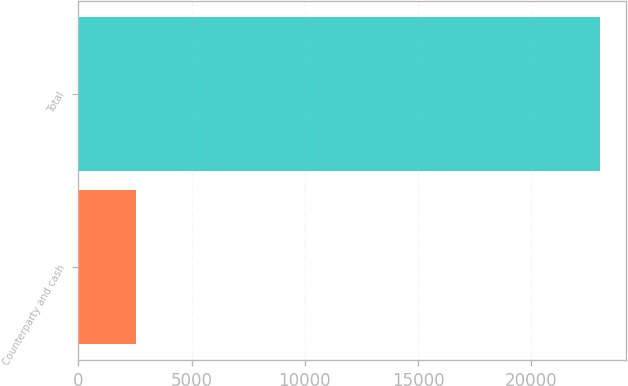Convert chart to OTSL. <chart><loc_0><loc_0><loc_500><loc_500><bar_chart><fcel>Counterparty and cash<fcel>Total<nl><fcel>2559<fcel>23029<nl></chart> 